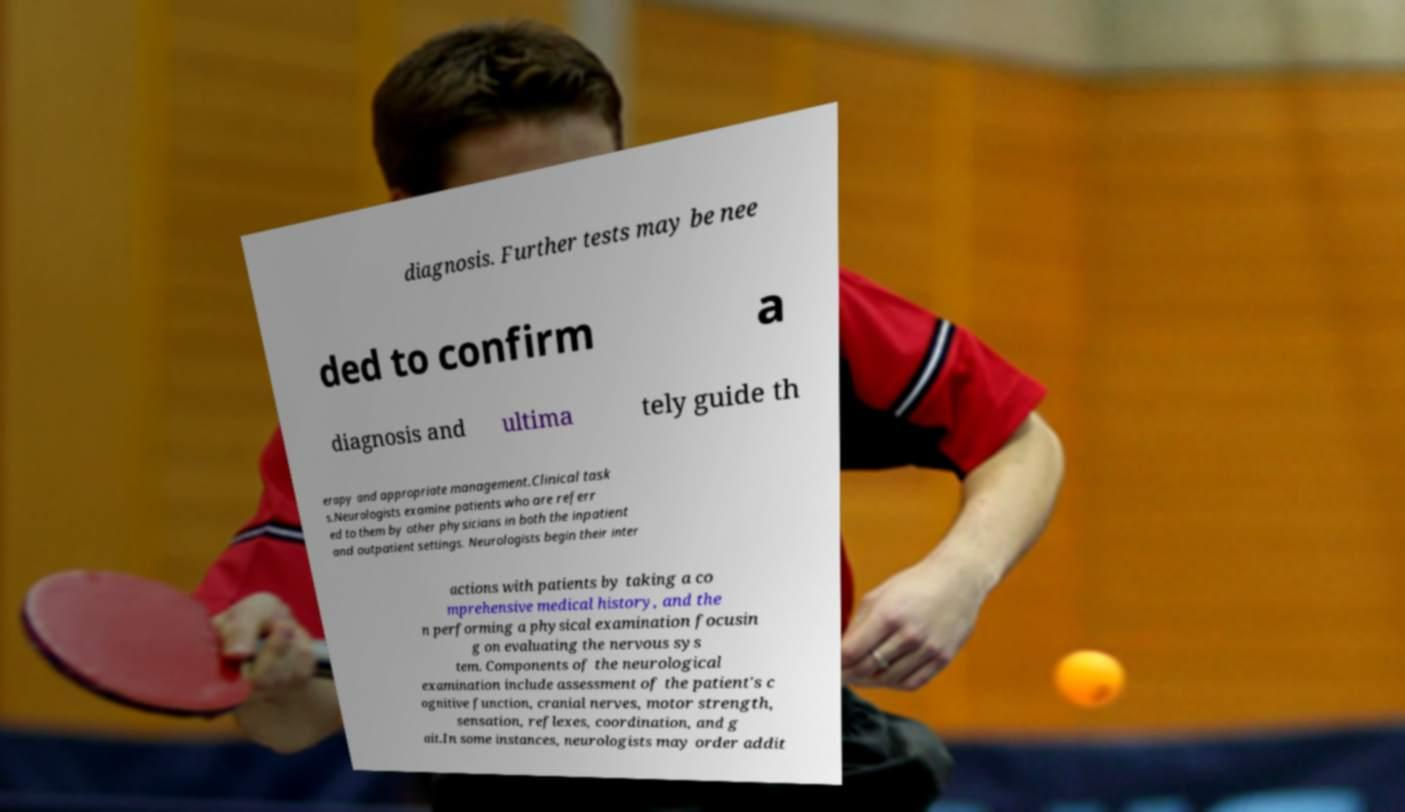I need the written content from this picture converted into text. Can you do that? diagnosis. Further tests may be nee ded to confirm a diagnosis and ultima tely guide th erapy and appropriate management.Clinical task s.Neurologists examine patients who are referr ed to them by other physicians in both the inpatient and outpatient settings. Neurologists begin their inter actions with patients by taking a co mprehensive medical history, and the n performing a physical examination focusin g on evaluating the nervous sys tem. Components of the neurological examination include assessment of the patient's c ognitive function, cranial nerves, motor strength, sensation, reflexes, coordination, and g ait.In some instances, neurologists may order addit 